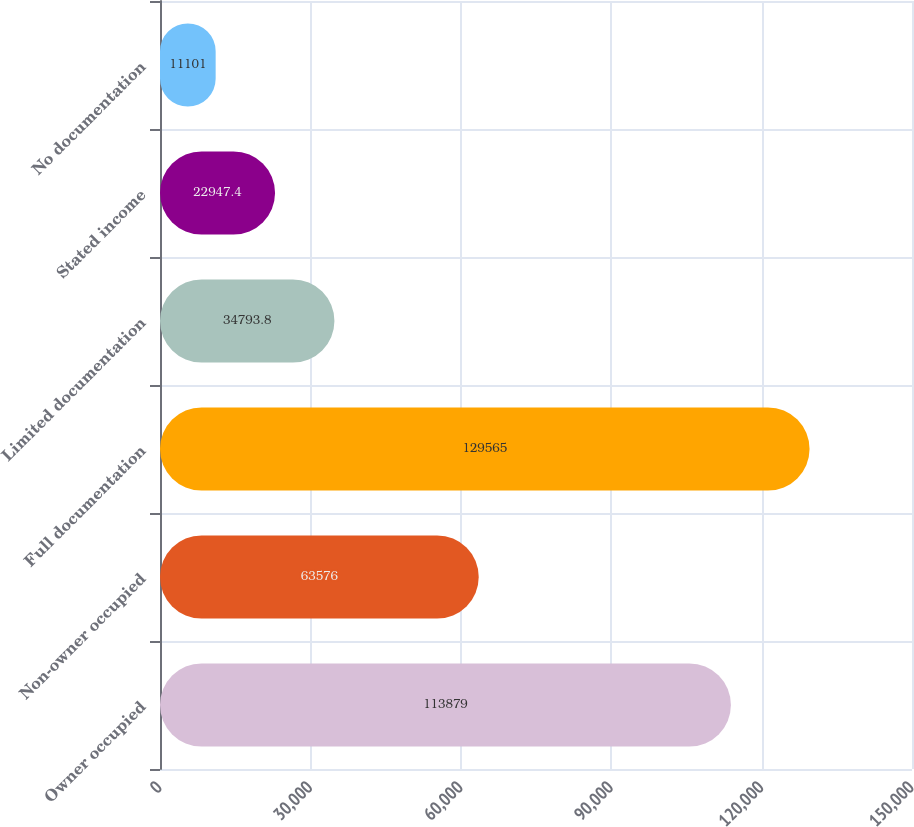Convert chart. <chart><loc_0><loc_0><loc_500><loc_500><bar_chart><fcel>Owner occupied<fcel>Non-owner occupied<fcel>Full documentation<fcel>Limited documentation<fcel>Stated income<fcel>No documentation<nl><fcel>113879<fcel>63576<fcel>129565<fcel>34793.8<fcel>22947.4<fcel>11101<nl></chart> 